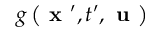Convert formula to latex. <formula><loc_0><loc_0><loc_500><loc_500>g \left ( x ^ { \prime } , t ^ { \prime } , u \right )</formula> 